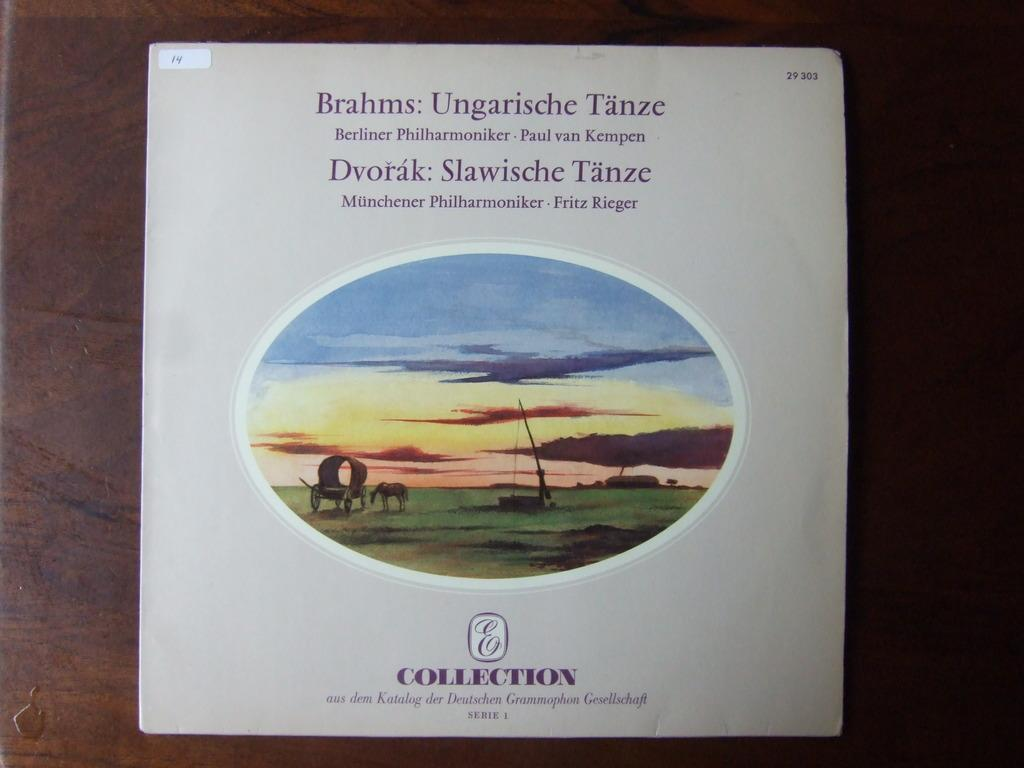<image>
Create a compact narrative representing the image presented. A cd cover with a picture of a horizon on it and Collection written at the bottom. 